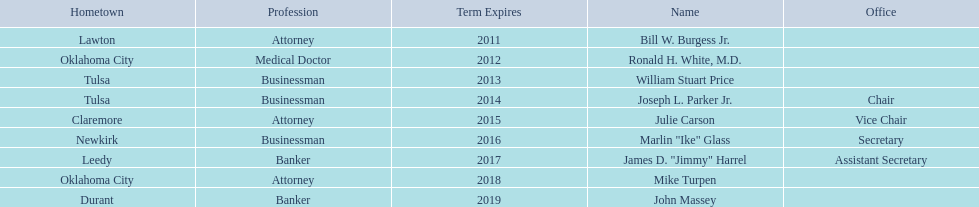Other members of the state regents from tulsa besides joseph l. parker jr. William Stuart Price. 